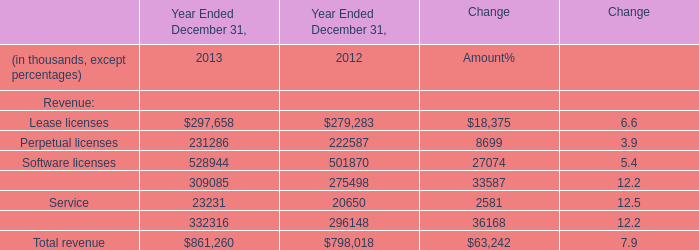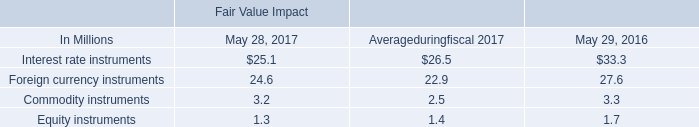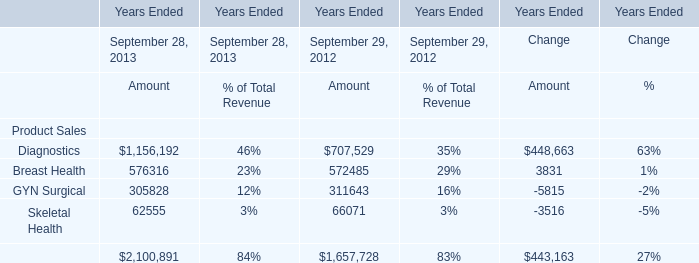What is the sum of Software licenses of Year Ended December 31, 2013, and Diagnostics of Years Ended Change Amount ? 
Computations: (528944.0 + 448663.0)
Answer: 977607.0. 